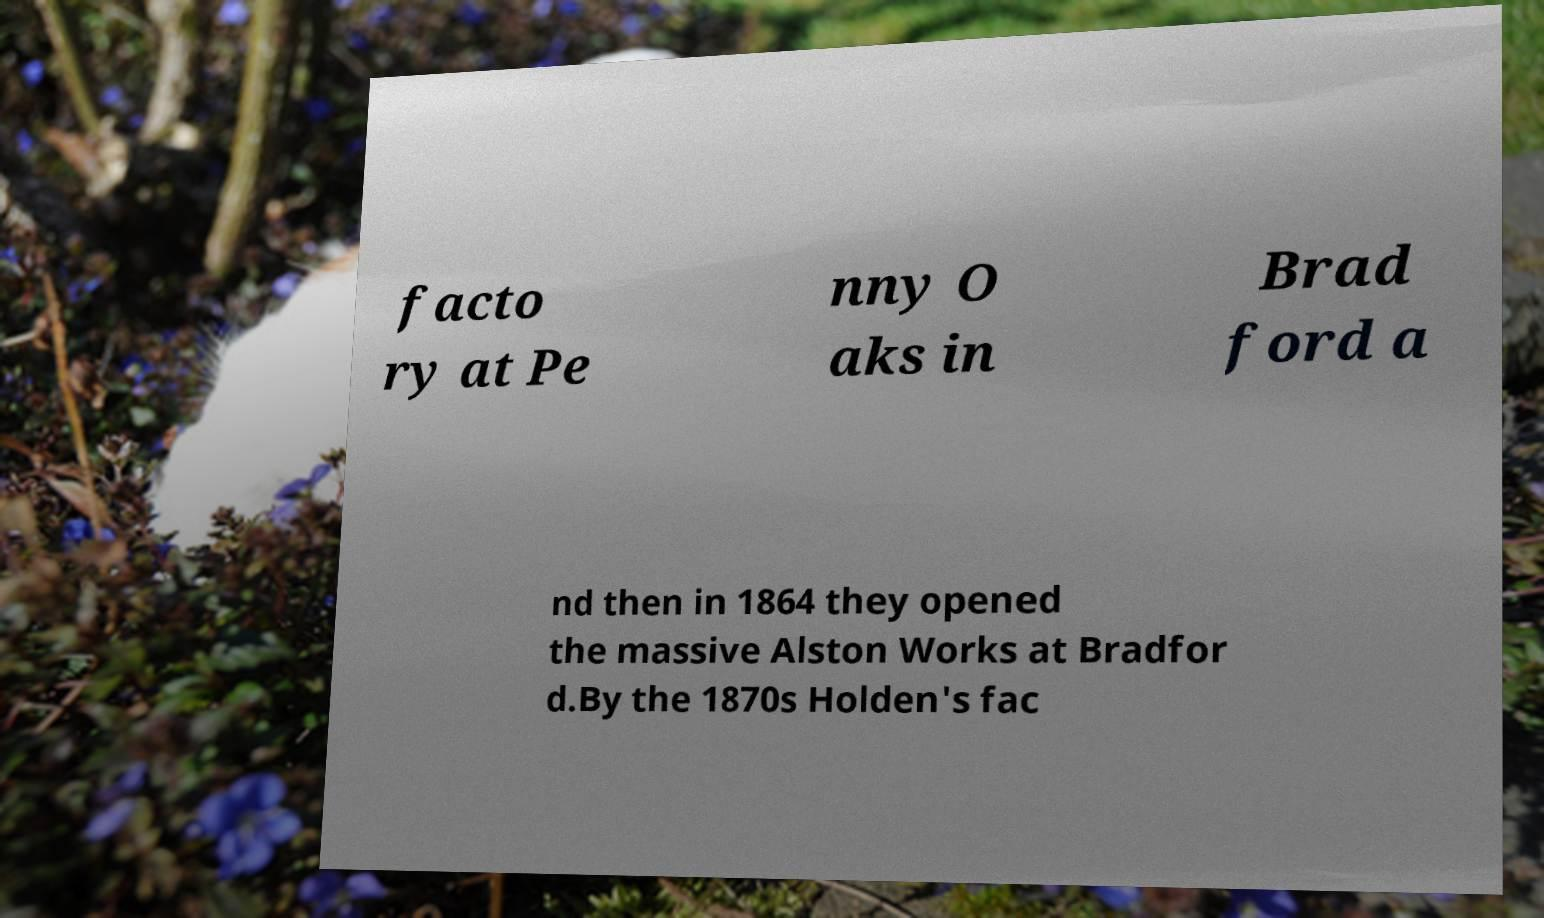Please read and relay the text visible in this image. What does it say? facto ry at Pe nny O aks in Brad ford a nd then in 1864 they opened the massive Alston Works at Bradfor d.By the 1870s Holden's fac 